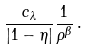<formula> <loc_0><loc_0><loc_500><loc_500>\frac { c _ { \lambda } } { | 1 - \eta | } \frac { 1 } { \rho ^ { \beta } } \, .</formula> 